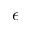<formula> <loc_0><loc_0><loc_500><loc_500>\epsilon</formula> 